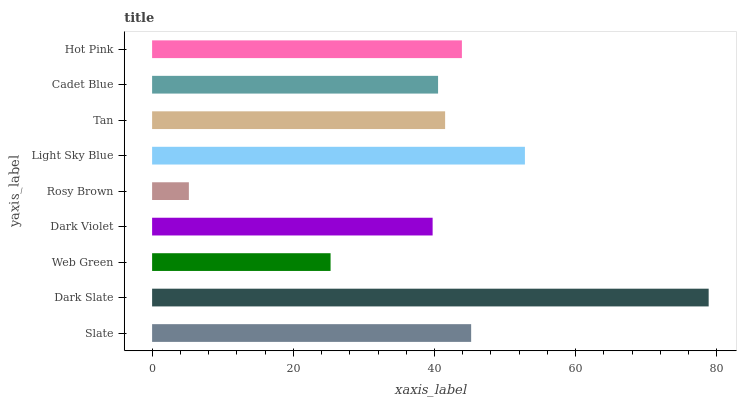Is Rosy Brown the minimum?
Answer yes or no. Yes. Is Dark Slate the maximum?
Answer yes or no. Yes. Is Web Green the minimum?
Answer yes or no. No. Is Web Green the maximum?
Answer yes or no. No. Is Dark Slate greater than Web Green?
Answer yes or no. Yes. Is Web Green less than Dark Slate?
Answer yes or no. Yes. Is Web Green greater than Dark Slate?
Answer yes or no. No. Is Dark Slate less than Web Green?
Answer yes or no. No. Is Tan the high median?
Answer yes or no. Yes. Is Tan the low median?
Answer yes or no. Yes. Is Rosy Brown the high median?
Answer yes or no. No. Is Dark Slate the low median?
Answer yes or no. No. 